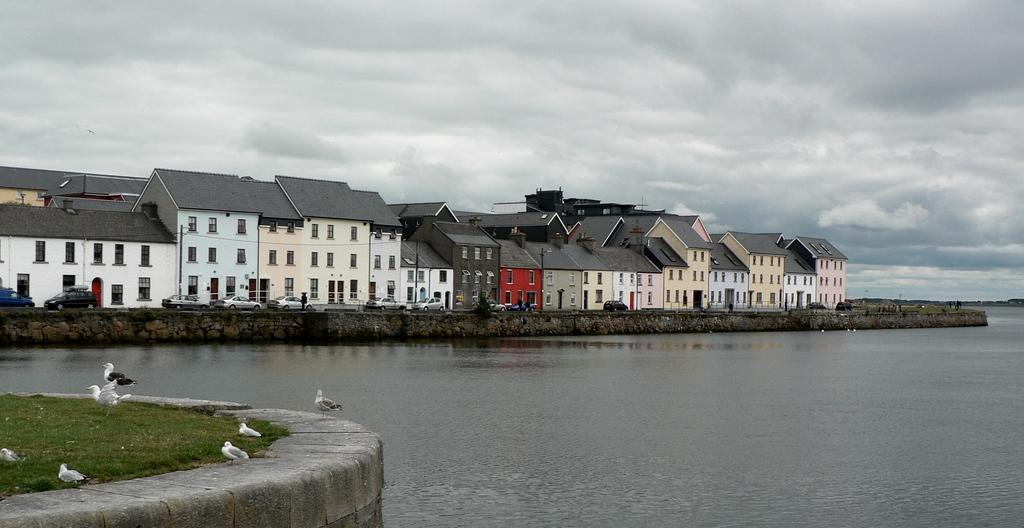What type of structures can be seen in the image? There are buildings in the image. What natural feature is visible in the image? There is sea visible in the image. What type of terrain is on the left side of the image? Grassy land is present on the left side of the image. What type of animals are present in the image? Birds are present in the image. How would you describe the sky in the image? The sky is full of clouds. What type of celery is being used as a decoration in the bedroom in the image? There is no bedroom or celery present in the image. Can you tell me how many flies are buzzing around the birds in the image? There are no flies present in the image; only birds are visible. 